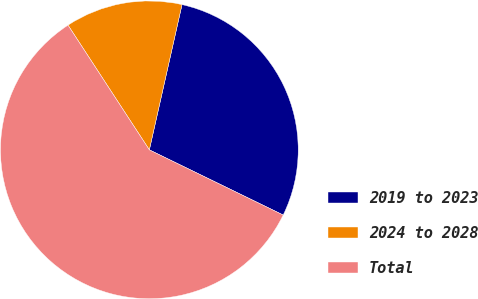Convert chart to OTSL. <chart><loc_0><loc_0><loc_500><loc_500><pie_chart><fcel>2019 to 2023<fcel>2024 to 2028<fcel>Total<nl><fcel>28.69%<fcel>12.72%<fcel>58.59%<nl></chart> 